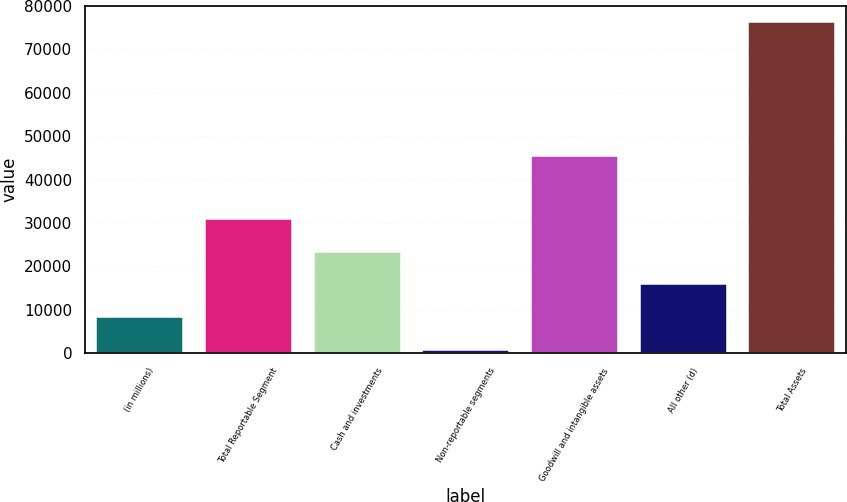Convert chart to OTSL. <chart><loc_0><loc_0><loc_500><loc_500><bar_chart><fcel>(in millions)<fcel>Total Reportable Segment<fcel>Cash and investments<fcel>Non-reportable segments<fcel>Goodwill and intangible assets<fcel>All other (d)<fcel>Total Assets<nl><fcel>8291<fcel>30944<fcel>23393<fcel>740<fcel>45493<fcel>15842<fcel>76250<nl></chart> 